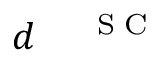<formula> <loc_0><loc_0><loc_500><loc_500>{ d ^ { \, { S C } } }</formula> 